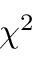Convert formula to latex. <formula><loc_0><loc_0><loc_500><loc_500>\chi ^ { 2 }</formula> 